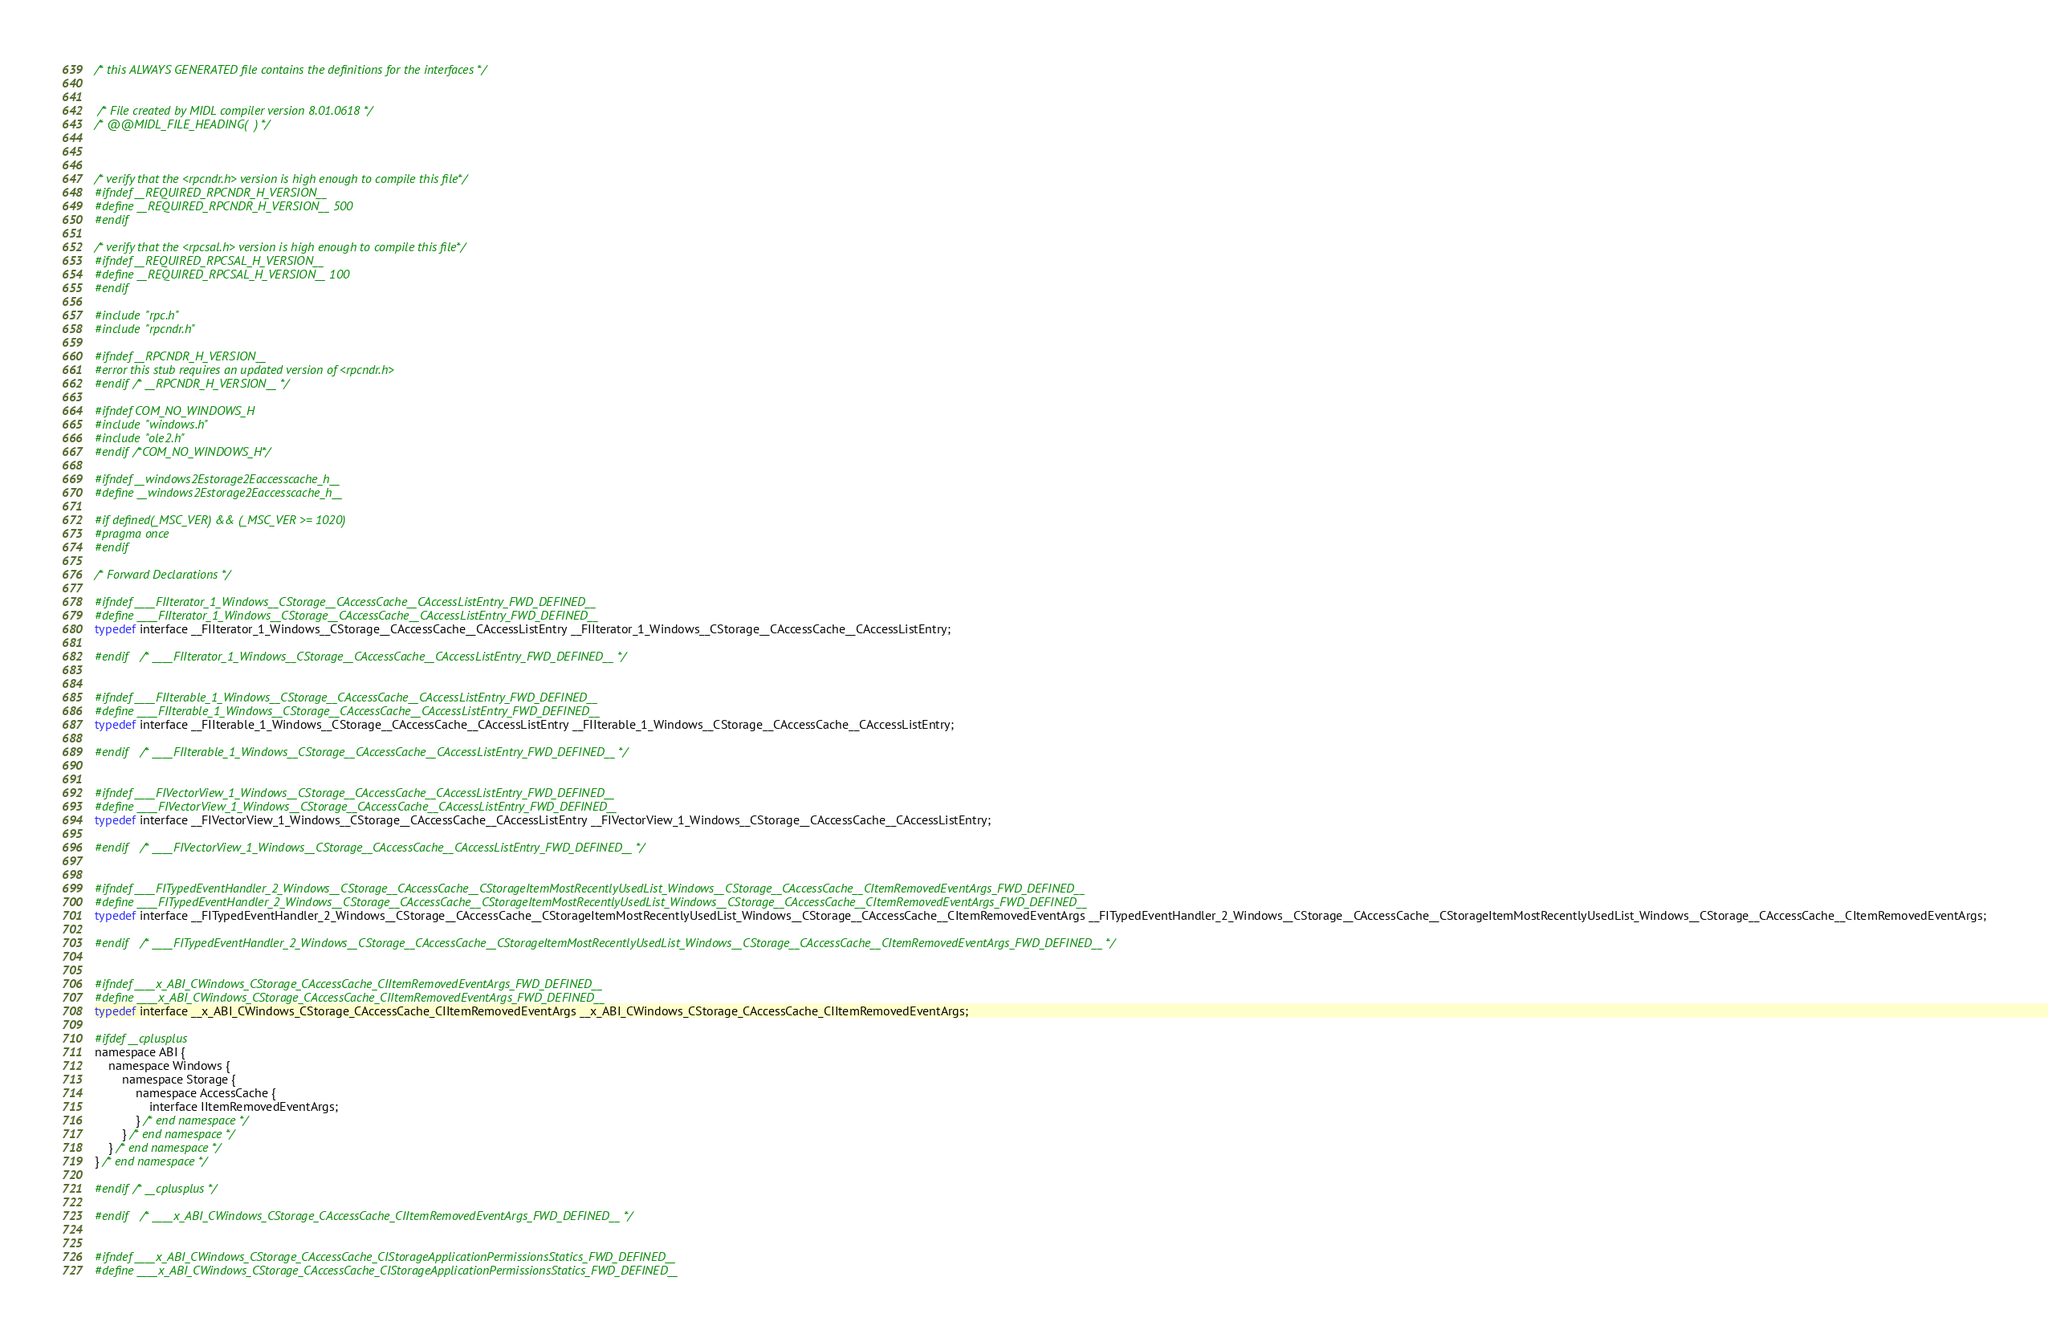Convert code to text. <code><loc_0><loc_0><loc_500><loc_500><_C_>

/* this ALWAYS GENERATED file contains the definitions for the interfaces */


 /* File created by MIDL compiler version 8.01.0618 */
/* @@MIDL_FILE_HEADING(  ) */



/* verify that the <rpcndr.h> version is high enough to compile this file*/
#ifndef __REQUIRED_RPCNDR_H_VERSION__
#define __REQUIRED_RPCNDR_H_VERSION__ 500
#endif

/* verify that the <rpcsal.h> version is high enough to compile this file*/
#ifndef __REQUIRED_RPCSAL_H_VERSION__
#define __REQUIRED_RPCSAL_H_VERSION__ 100
#endif

#include "rpc.h"
#include "rpcndr.h"

#ifndef __RPCNDR_H_VERSION__
#error this stub requires an updated version of <rpcndr.h>
#endif /* __RPCNDR_H_VERSION__ */

#ifndef COM_NO_WINDOWS_H
#include "windows.h"
#include "ole2.h"
#endif /*COM_NO_WINDOWS_H*/

#ifndef __windows2Estorage2Eaccesscache_h__
#define __windows2Estorage2Eaccesscache_h__

#if defined(_MSC_VER) && (_MSC_VER >= 1020)
#pragma once
#endif

/* Forward Declarations */ 

#ifndef ____FIIterator_1_Windows__CStorage__CAccessCache__CAccessListEntry_FWD_DEFINED__
#define ____FIIterator_1_Windows__CStorage__CAccessCache__CAccessListEntry_FWD_DEFINED__
typedef interface __FIIterator_1_Windows__CStorage__CAccessCache__CAccessListEntry __FIIterator_1_Windows__CStorage__CAccessCache__CAccessListEntry;

#endif 	/* ____FIIterator_1_Windows__CStorage__CAccessCache__CAccessListEntry_FWD_DEFINED__ */


#ifndef ____FIIterable_1_Windows__CStorage__CAccessCache__CAccessListEntry_FWD_DEFINED__
#define ____FIIterable_1_Windows__CStorage__CAccessCache__CAccessListEntry_FWD_DEFINED__
typedef interface __FIIterable_1_Windows__CStorage__CAccessCache__CAccessListEntry __FIIterable_1_Windows__CStorage__CAccessCache__CAccessListEntry;

#endif 	/* ____FIIterable_1_Windows__CStorage__CAccessCache__CAccessListEntry_FWD_DEFINED__ */


#ifndef ____FIVectorView_1_Windows__CStorage__CAccessCache__CAccessListEntry_FWD_DEFINED__
#define ____FIVectorView_1_Windows__CStorage__CAccessCache__CAccessListEntry_FWD_DEFINED__
typedef interface __FIVectorView_1_Windows__CStorage__CAccessCache__CAccessListEntry __FIVectorView_1_Windows__CStorage__CAccessCache__CAccessListEntry;

#endif 	/* ____FIVectorView_1_Windows__CStorage__CAccessCache__CAccessListEntry_FWD_DEFINED__ */


#ifndef ____FITypedEventHandler_2_Windows__CStorage__CAccessCache__CStorageItemMostRecentlyUsedList_Windows__CStorage__CAccessCache__CItemRemovedEventArgs_FWD_DEFINED__
#define ____FITypedEventHandler_2_Windows__CStorage__CAccessCache__CStorageItemMostRecentlyUsedList_Windows__CStorage__CAccessCache__CItemRemovedEventArgs_FWD_DEFINED__
typedef interface __FITypedEventHandler_2_Windows__CStorage__CAccessCache__CStorageItemMostRecentlyUsedList_Windows__CStorage__CAccessCache__CItemRemovedEventArgs __FITypedEventHandler_2_Windows__CStorage__CAccessCache__CStorageItemMostRecentlyUsedList_Windows__CStorage__CAccessCache__CItemRemovedEventArgs;

#endif 	/* ____FITypedEventHandler_2_Windows__CStorage__CAccessCache__CStorageItemMostRecentlyUsedList_Windows__CStorage__CAccessCache__CItemRemovedEventArgs_FWD_DEFINED__ */


#ifndef ____x_ABI_CWindows_CStorage_CAccessCache_CIItemRemovedEventArgs_FWD_DEFINED__
#define ____x_ABI_CWindows_CStorage_CAccessCache_CIItemRemovedEventArgs_FWD_DEFINED__
typedef interface __x_ABI_CWindows_CStorage_CAccessCache_CIItemRemovedEventArgs __x_ABI_CWindows_CStorage_CAccessCache_CIItemRemovedEventArgs;

#ifdef __cplusplus
namespace ABI {
    namespace Windows {
        namespace Storage {
            namespace AccessCache {
                interface IItemRemovedEventArgs;
            } /* end namespace */
        } /* end namespace */
    } /* end namespace */
} /* end namespace */

#endif /* __cplusplus */

#endif 	/* ____x_ABI_CWindows_CStorage_CAccessCache_CIItemRemovedEventArgs_FWD_DEFINED__ */


#ifndef ____x_ABI_CWindows_CStorage_CAccessCache_CIStorageApplicationPermissionsStatics_FWD_DEFINED__
#define ____x_ABI_CWindows_CStorage_CAccessCache_CIStorageApplicationPermissionsStatics_FWD_DEFINED__</code> 